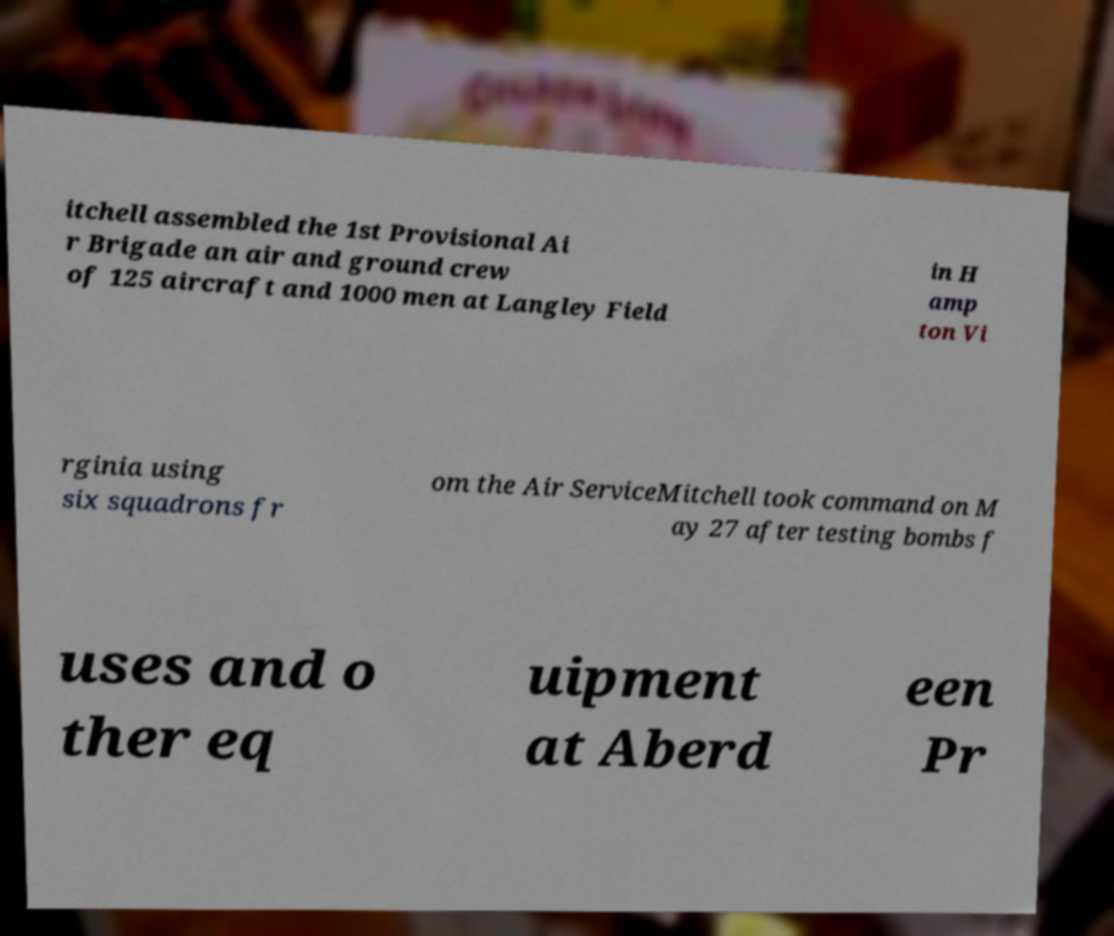For documentation purposes, I need the text within this image transcribed. Could you provide that? itchell assembled the 1st Provisional Ai r Brigade an air and ground crew of 125 aircraft and 1000 men at Langley Field in H amp ton Vi rginia using six squadrons fr om the Air ServiceMitchell took command on M ay 27 after testing bombs f uses and o ther eq uipment at Aberd een Pr 